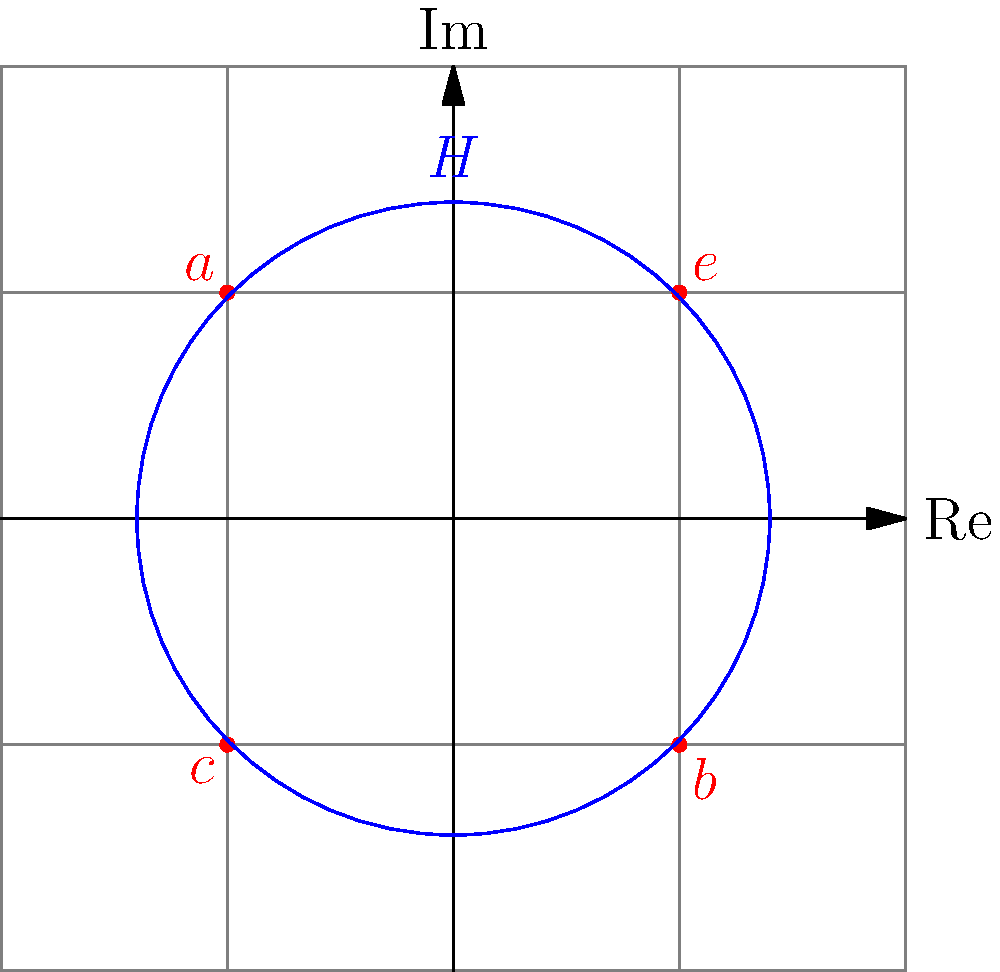In power flow analysis of wind-integrated grids, consider a symmetry group $G = \{e, a, b, c\}$ representing different configurations of wind turbine alignments. The subgroup $H = \{e, a\}$ represents configurations with minimal wake effects. Using the given diagram, determine the order of the quotient group $G/H$ and explain its significance in analyzing wind farm layouts. To solve this problem, let's follow these steps:

1) First, recall that the order of a quotient group $G/H$ is equal to the number of left cosets of $H$ in $G$. The number of left cosets is equal to the index of $H$ in $G$, denoted as $[G:H]$.

2) The index $[G:H]$ can be calculated using Lagrange's theorem:

   $[G:H] = \frac{|G|}{|H|}$

   where $|G|$ is the order of group $G$ and $|H|$ is the order of subgroup $H$.

3) From the diagram, we can see that:
   $|G| = 4$ (elements $e, a, b, c$)
   $|H| = 2$ (elements $e, a$)

4) Applying Lagrange's theorem:

   $[G:H] = \frac{|G|}{|H|} = \frac{4}{2} = 2$

5) Therefore, the order of the quotient group $G/H$ is 2.

6) Significance in wind farm layout analysis:
   - The quotient group $G/H$ represents the distinct classes of turbine configurations that produce different wake effects.
   - An order of 2 means there are two fundamentally different classes of configurations: those with minimal wake effects (represented by $H$) and those with significant wake interactions.
   - This grouping can help simplify the analysis of complex wind farm layouts by categorizing configurations based on their wake interaction patterns.
Answer: Order of $G/H$ is 2, representing two classes of wind turbine configurations based on wake effects. 